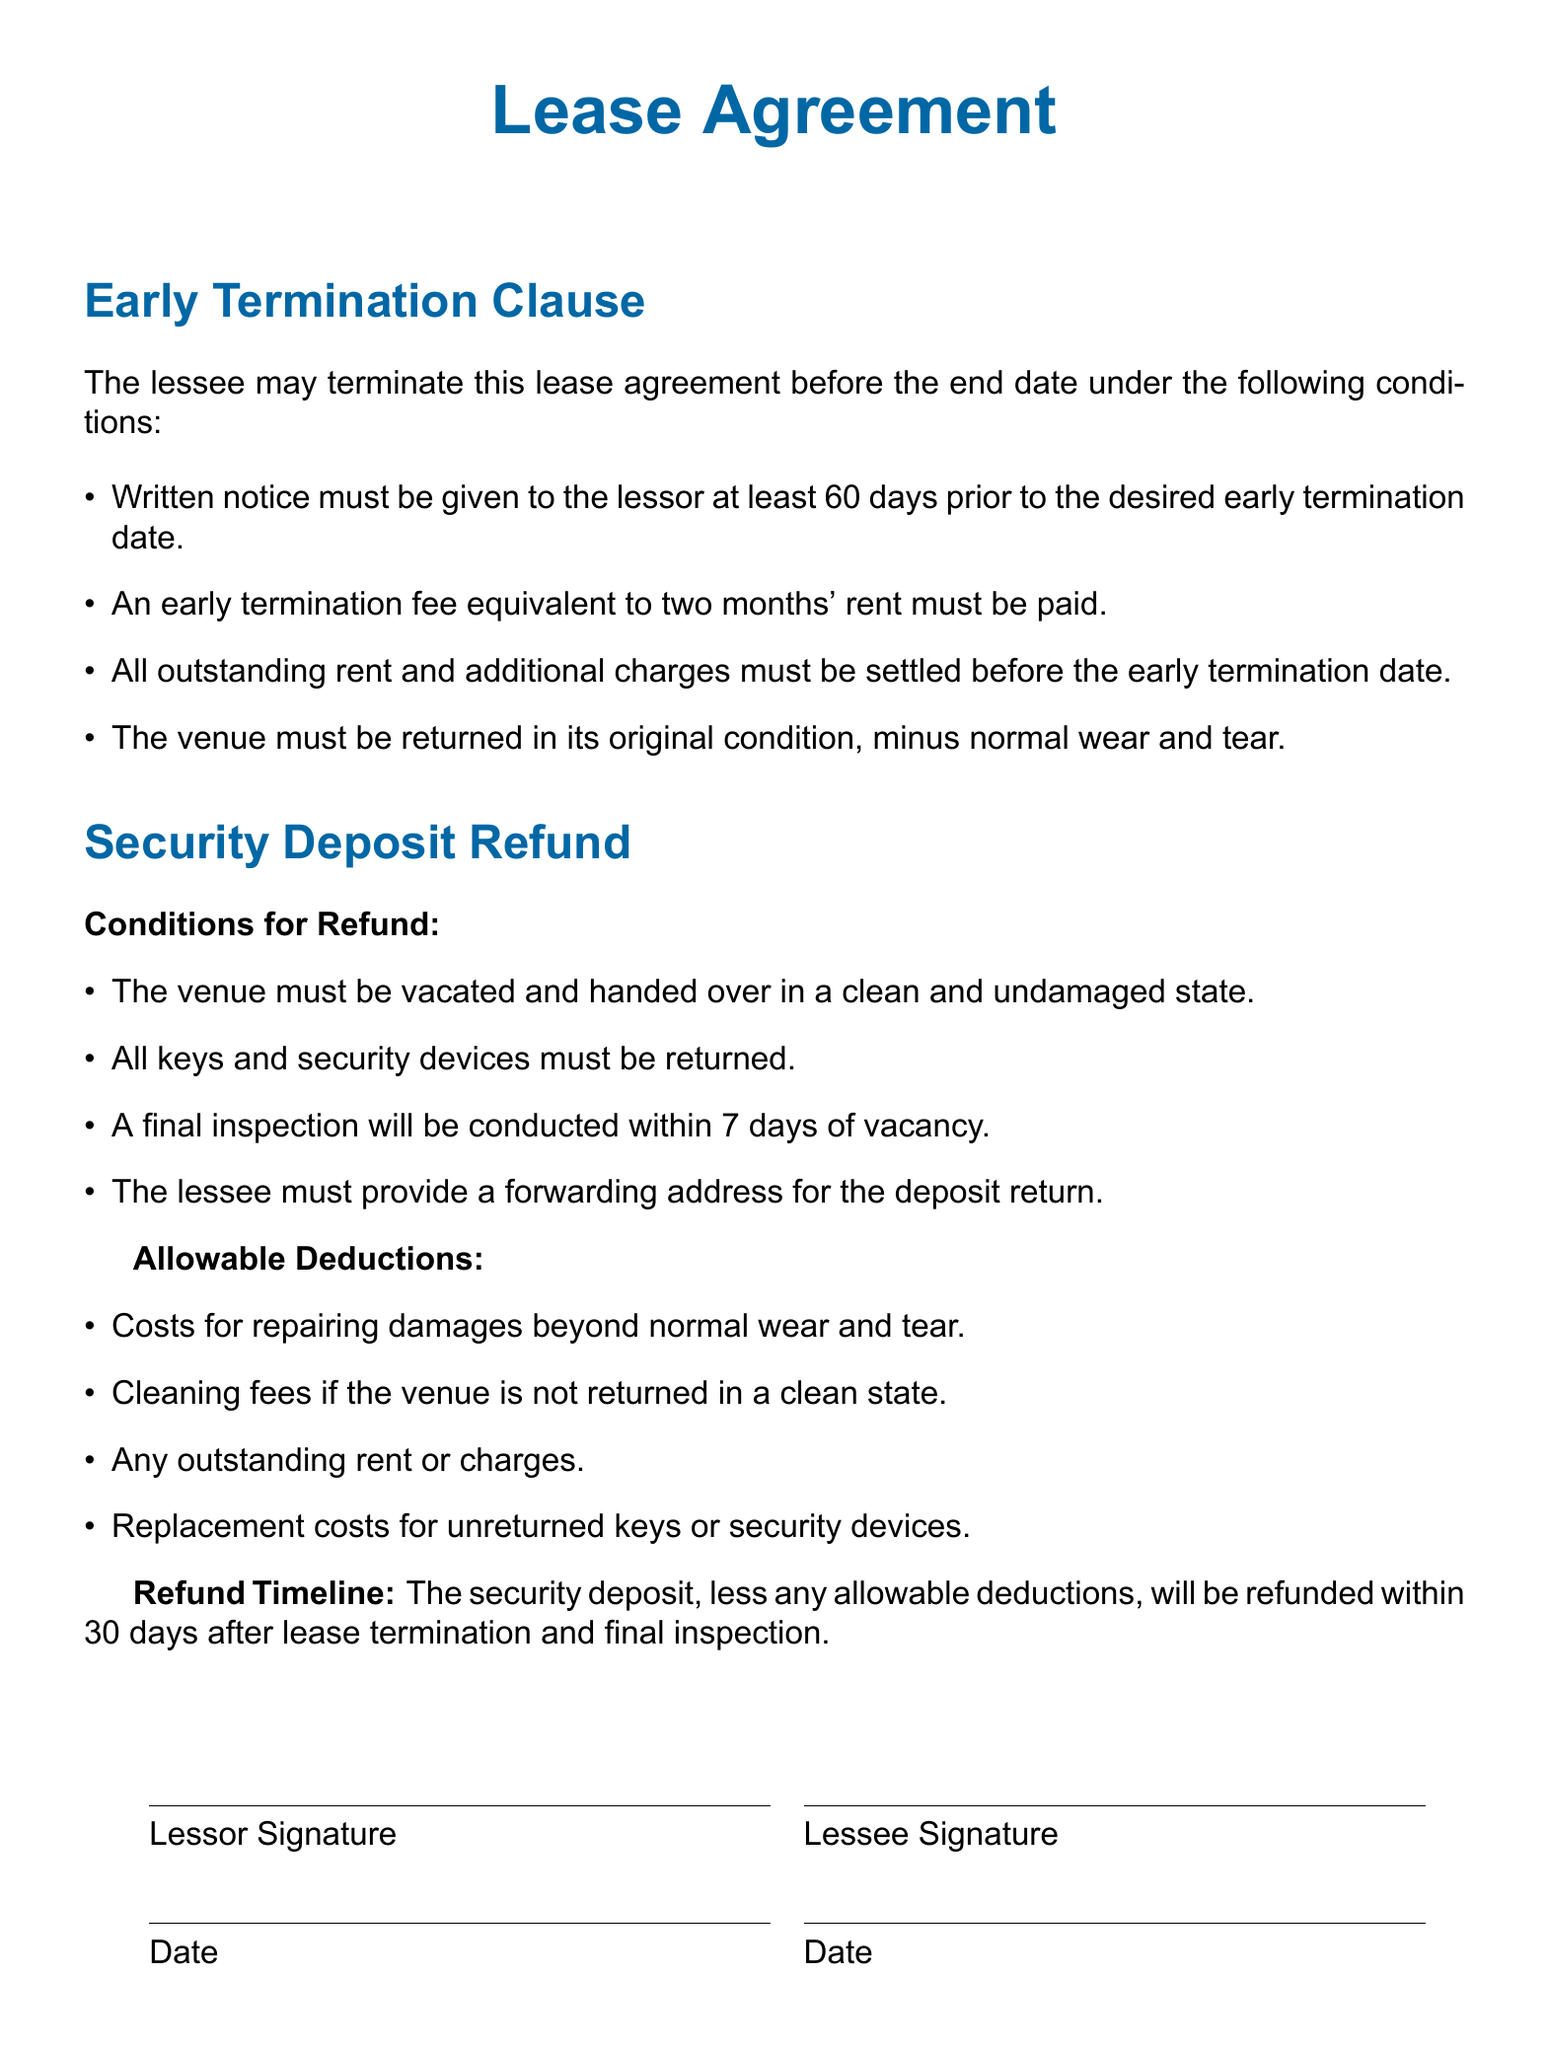What is the notice period for early termination? The notice period required for early termination is stated as 60 days.
Answer: 60 days What is the early termination fee? The early termination fee is indicated as equivalent to two months' rent.
Answer: Two months' rent What condition must be met for the venue during early termination? The venue must be returned in its original condition, minus normal wear and tear, as specified in the document.
Answer: Original condition What is the final inspection timeline? The final inspection is specified to be conducted within 7 days of vacancy.
Answer: 7 days What is required to receive the security deposit refund? The document states that all keys and security devices must be returned to receive the security deposit refund.
Answer: All keys and security devices What is the maximum time frame to receive a security deposit refund? The time frame specified for the refund of the security deposit is 30 days after lease termination and final inspection.
Answer: 30 days What may be deducted from the security deposit refund? The document lists that costs for repairing damages beyond normal wear and tear may be deducted from the security deposit refund.
Answer: Damages beyond normal wear and tear Who must sign the lease agreement? The lease agreement must be signed by both the lessor and the lessee.
Answer: Both lessor and lessee What must the lessee provide for the deposit return? A forwarding address for the deposit return must be provided by the lessee.
Answer: Forwarding address 